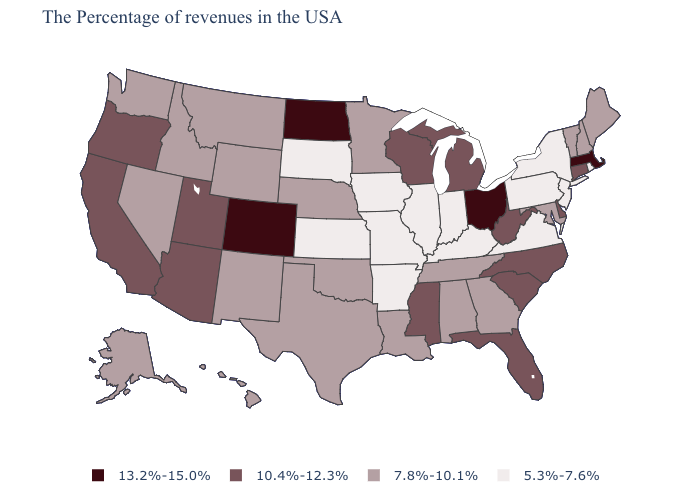What is the value of Washington?
Quick response, please. 7.8%-10.1%. Among the states that border Missouri , does Kansas have the lowest value?
Answer briefly. Yes. Does North Dakota have the highest value in the MidWest?
Keep it brief. Yes. What is the value of Pennsylvania?
Give a very brief answer. 5.3%-7.6%. Name the states that have a value in the range 7.8%-10.1%?
Be succinct. Maine, New Hampshire, Vermont, Maryland, Georgia, Alabama, Tennessee, Louisiana, Minnesota, Nebraska, Oklahoma, Texas, Wyoming, New Mexico, Montana, Idaho, Nevada, Washington, Alaska, Hawaii. Which states have the lowest value in the Northeast?
Answer briefly. Rhode Island, New York, New Jersey, Pennsylvania. Which states have the lowest value in the West?
Write a very short answer. Wyoming, New Mexico, Montana, Idaho, Nevada, Washington, Alaska, Hawaii. What is the value of New Mexico?
Answer briefly. 7.8%-10.1%. Does Wisconsin have the same value as North Dakota?
Answer briefly. No. What is the value of Montana?
Be succinct. 7.8%-10.1%. Does Kentucky have the lowest value in the South?
Write a very short answer. Yes. What is the lowest value in the USA?
Answer briefly. 5.3%-7.6%. Among the states that border Kansas , which have the lowest value?
Be succinct. Missouri. Which states have the lowest value in the USA?
Give a very brief answer. Rhode Island, New York, New Jersey, Pennsylvania, Virginia, Kentucky, Indiana, Illinois, Missouri, Arkansas, Iowa, Kansas, South Dakota. Does New Hampshire have the lowest value in the USA?
Keep it brief. No. 